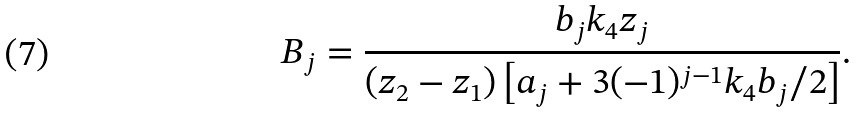<formula> <loc_0><loc_0><loc_500><loc_500>B _ { j } = \frac { b _ { j } k _ { 4 } z _ { j } } { ( z _ { 2 } - z _ { 1 } ) \left [ a _ { j } + 3 ( - 1 ) ^ { j - 1 } k _ { 4 } b _ { j } / 2 \right ] } .</formula> 